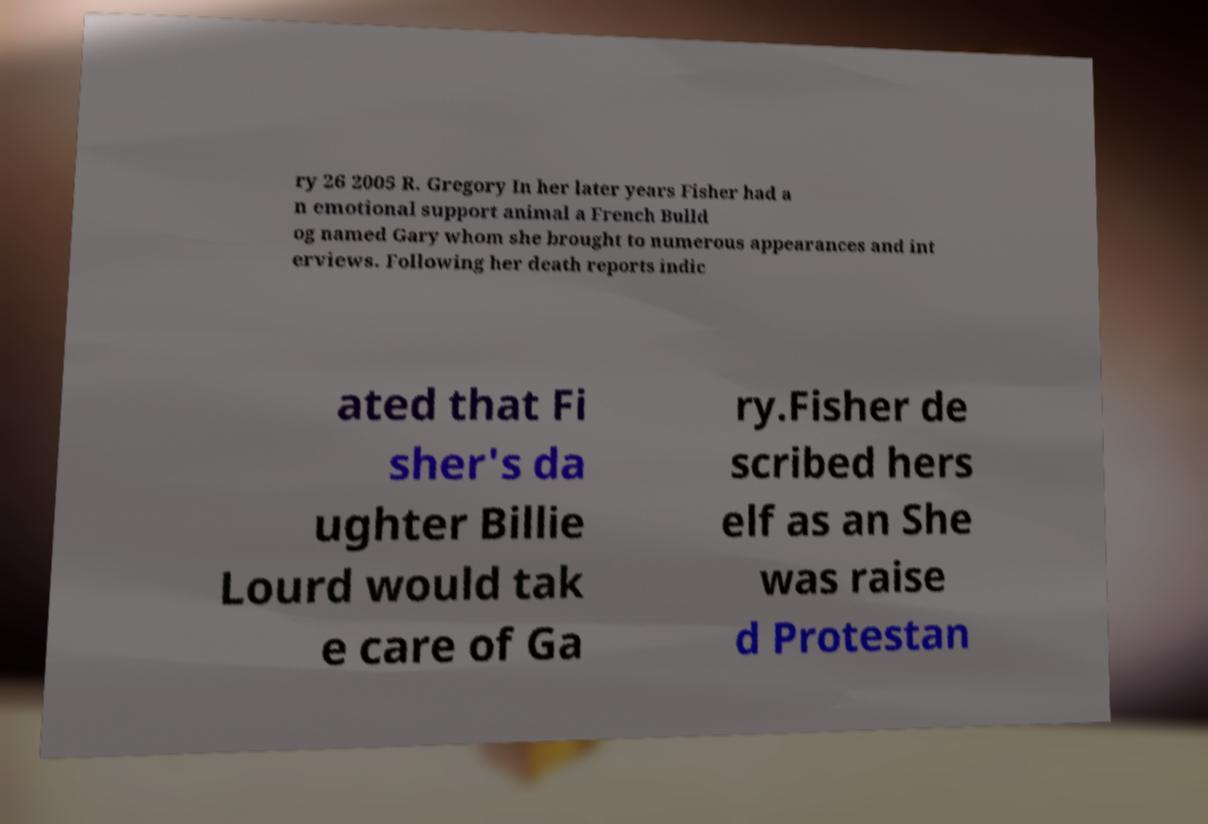Can you read and provide the text displayed in the image?This photo seems to have some interesting text. Can you extract and type it out for me? ry 26 2005 R. Gregory In her later years Fisher had a n emotional support animal a French Bulld og named Gary whom she brought to numerous appearances and int erviews. Following her death reports indic ated that Fi sher's da ughter Billie Lourd would tak e care of Ga ry.Fisher de scribed hers elf as an She was raise d Protestan 